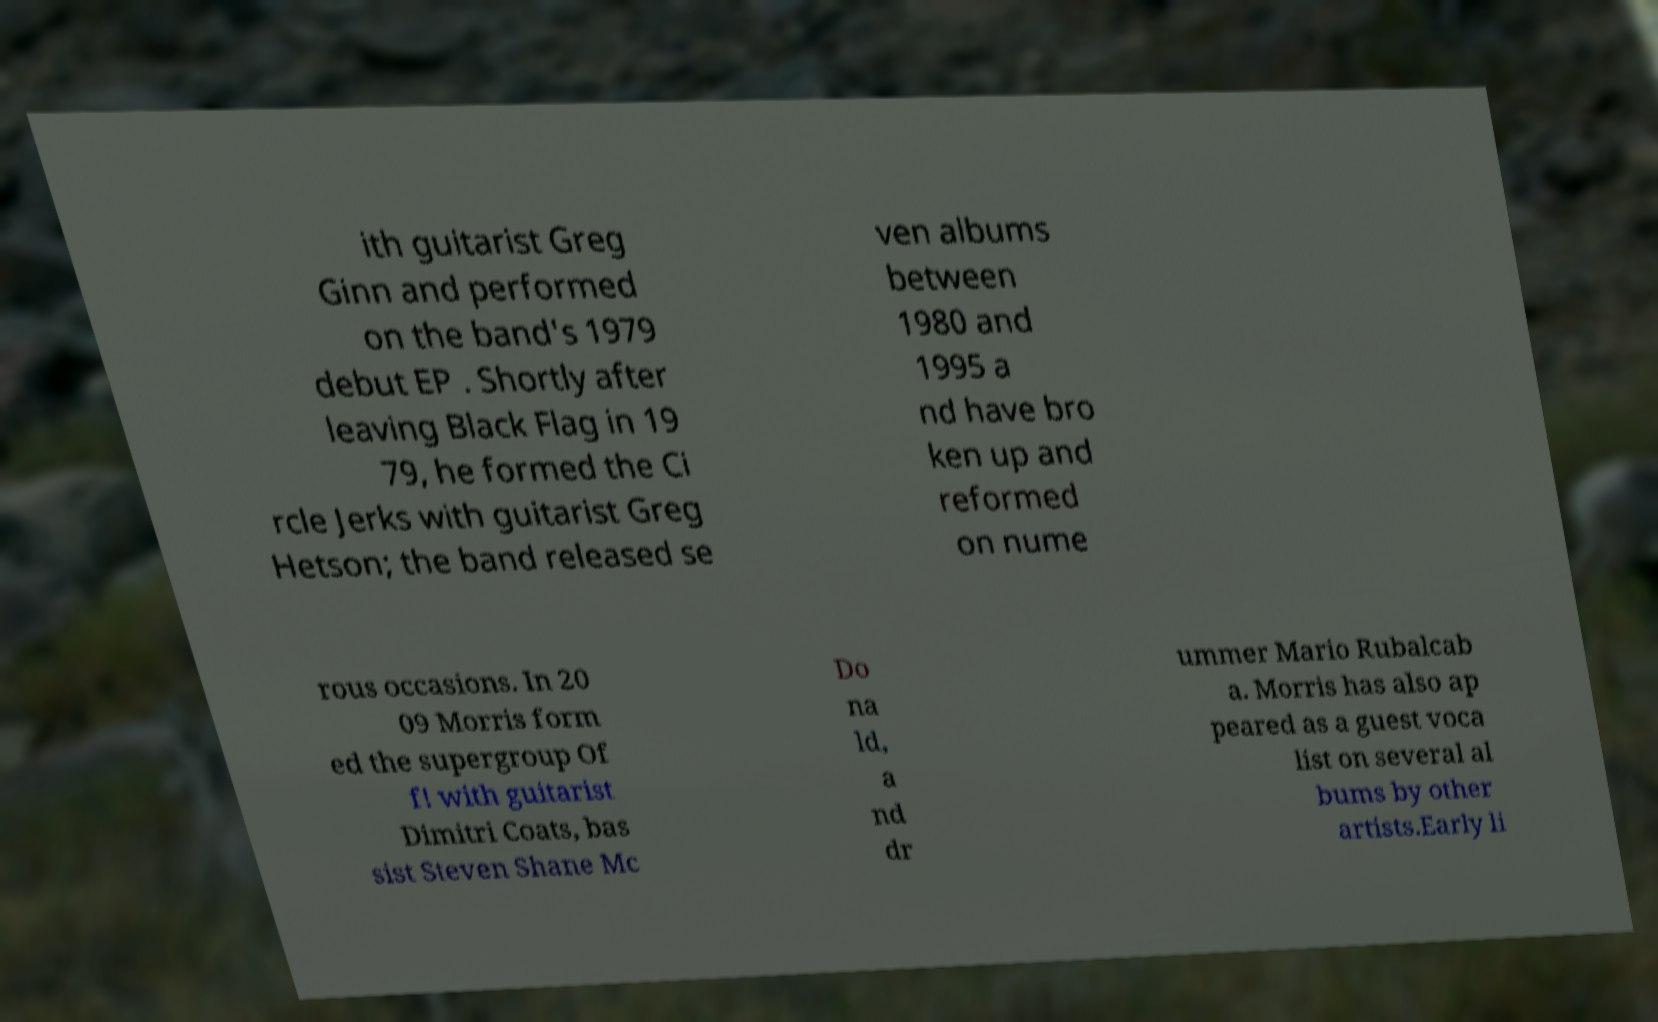There's text embedded in this image that I need extracted. Can you transcribe it verbatim? ith guitarist Greg Ginn and performed on the band's 1979 debut EP . Shortly after leaving Black Flag in 19 79, he formed the Ci rcle Jerks with guitarist Greg Hetson; the band released se ven albums between 1980 and 1995 a nd have bro ken up and reformed on nume rous occasions. In 20 09 Morris form ed the supergroup Of f! with guitarist Dimitri Coats, bas sist Steven Shane Mc Do na ld, a nd dr ummer Mario Rubalcab a. Morris has also ap peared as a guest voca list on several al bums by other artists.Early li 